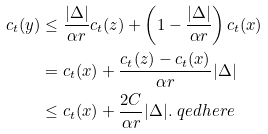Convert formula to latex. <formula><loc_0><loc_0><loc_500><loc_500>c _ { t } ( y ) & \leq \frac { | \Delta | } { \alpha r } c _ { t } ( z ) + \left ( 1 - \frac { | \Delta | } { \alpha r } \right ) c _ { t } ( x ) \\ & = c _ { t } ( x ) + \frac { c _ { t } ( z ) - c _ { t } ( x ) } { \alpha r } | \Delta | \\ & \leq c _ { t } ( x ) + \frac { 2 C } { \alpha r } | \Delta | . \ q e d h e r e</formula> 